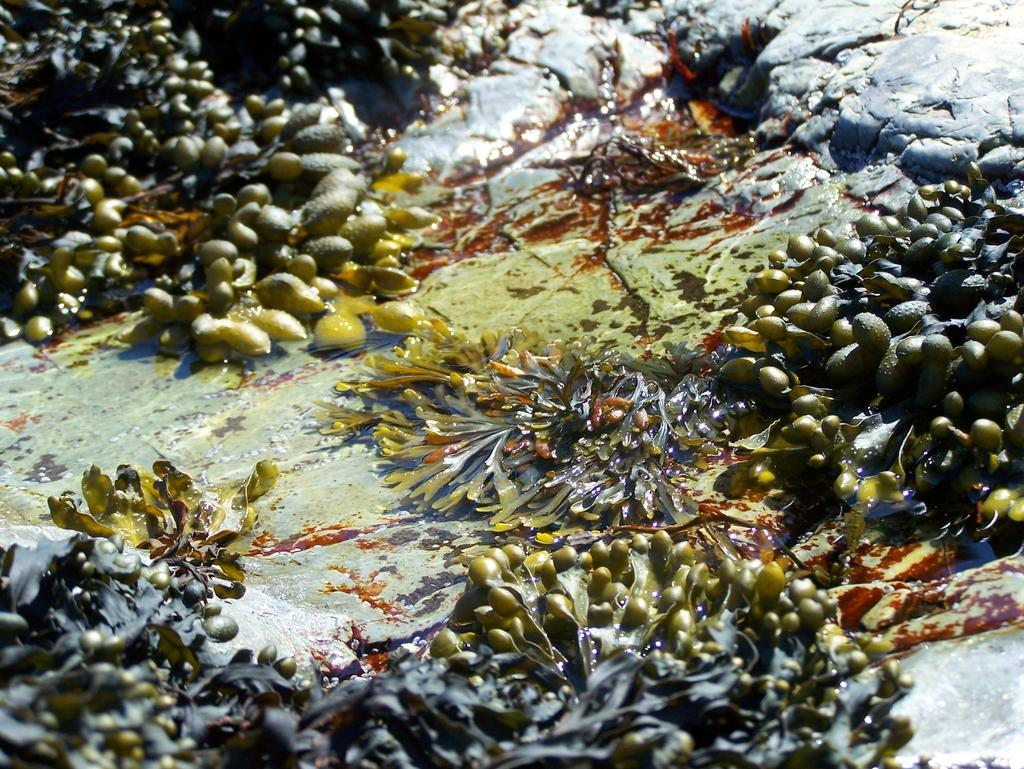What type of living organisms can be seen in the image? Plants can be seen in the image. What colors are the plants in the image? The plants are in green and grey color. What else is visible in the image besides the plants? There is water and a rock visible in the image. What color is the rock in the image? The rock is in ash color. What type of pan is being used to create the design on the rock in the image? There is no pan or design present on the rock in the image; it is a natural rock formation. 